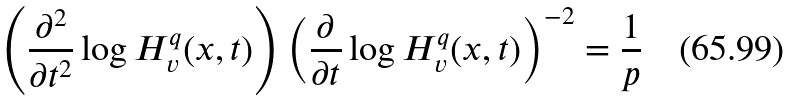Convert formula to latex. <formula><loc_0><loc_0><loc_500><loc_500>\left ( \frac { \partial ^ { 2 } } { \partial t ^ { 2 } } \log H _ { v } ^ { q } ( x , t ) \right ) \left ( \frac { \partial } { \partial t } \log H _ { v } ^ { q } ( x , t ) \right ) ^ { - 2 } = \frac { 1 } { p }</formula> 